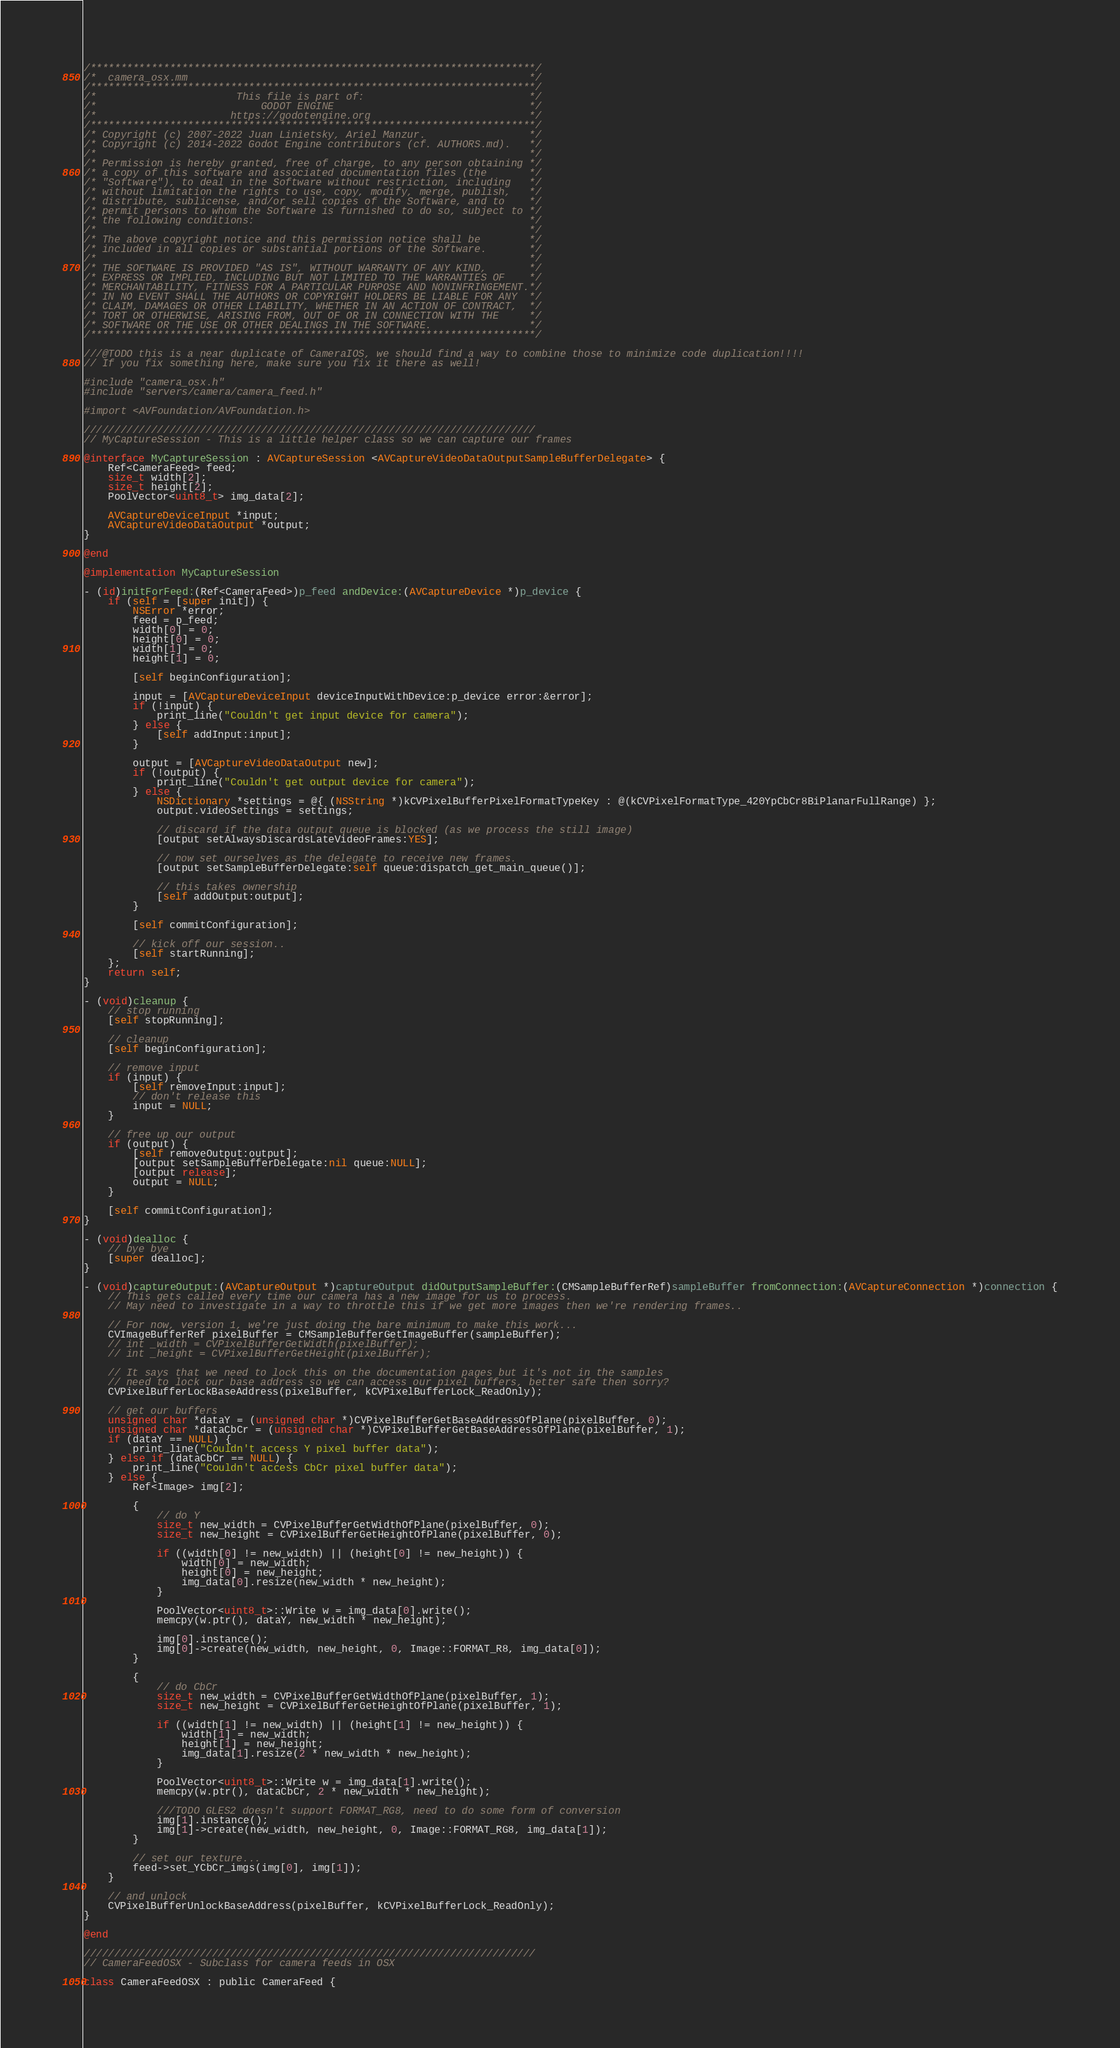Convert code to text. <code><loc_0><loc_0><loc_500><loc_500><_ObjectiveC_>/*************************************************************************/
/*  camera_osx.mm                                                        */
/*************************************************************************/
/*                       This file is part of:                           */
/*                           GODOT ENGINE                                */
/*                      https://godotengine.org                          */
/*************************************************************************/
/* Copyright (c) 2007-2022 Juan Linietsky, Ariel Manzur.                 */
/* Copyright (c) 2014-2022 Godot Engine contributors (cf. AUTHORS.md).   */
/*                                                                       */
/* Permission is hereby granted, free of charge, to any person obtaining */
/* a copy of this software and associated documentation files (the       */
/* "Software"), to deal in the Software without restriction, including   */
/* without limitation the rights to use, copy, modify, merge, publish,   */
/* distribute, sublicense, and/or sell copies of the Software, and to    */
/* permit persons to whom the Software is furnished to do so, subject to */
/* the following conditions:                                             */
/*                                                                       */
/* The above copyright notice and this permission notice shall be        */
/* included in all copies or substantial portions of the Software.       */
/*                                                                       */
/* THE SOFTWARE IS PROVIDED "AS IS", WITHOUT WARRANTY OF ANY KIND,       */
/* EXPRESS OR IMPLIED, INCLUDING BUT NOT LIMITED TO THE WARRANTIES OF    */
/* MERCHANTABILITY, FITNESS FOR A PARTICULAR PURPOSE AND NONINFRINGEMENT.*/
/* IN NO EVENT SHALL THE AUTHORS OR COPYRIGHT HOLDERS BE LIABLE FOR ANY  */
/* CLAIM, DAMAGES OR OTHER LIABILITY, WHETHER IN AN ACTION OF CONTRACT,  */
/* TORT OR OTHERWISE, ARISING FROM, OUT OF OR IN CONNECTION WITH THE     */
/* SOFTWARE OR THE USE OR OTHER DEALINGS IN THE SOFTWARE.                */
/*************************************************************************/

///@TODO this is a near duplicate of CameraIOS, we should find a way to combine those to minimize code duplication!!!!
// If you fix something here, make sure you fix it there as well!

#include "camera_osx.h"
#include "servers/camera/camera_feed.h"

#import <AVFoundation/AVFoundation.h>

//////////////////////////////////////////////////////////////////////////
// MyCaptureSession - This is a little helper class so we can capture our frames

@interface MyCaptureSession : AVCaptureSession <AVCaptureVideoDataOutputSampleBufferDelegate> {
	Ref<CameraFeed> feed;
	size_t width[2];
	size_t height[2];
	PoolVector<uint8_t> img_data[2];

	AVCaptureDeviceInput *input;
	AVCaptureVideoDataOutput *output;
}

@end

@implementation MyCaptureSession

- (id)initForFeed:(Ref<CameraFeed>)p_feed andDevice:(AVCaptureDevice *)p_device {
	if (self = [super init]) {
		NSError *error;
		feed = p_feed;
		width[0] = 0;
		height[0] = 0;
		width[1] = 0;
		height[1] = 0;

		[self beginConfiguration];

		input = [AVCaptureDeviceInput deviceInputWithDevice:p_device error:&error];
		if (!input) {
			print_line("Couldn't get input device for camera");
		} else {
			[self addInput:input];
		}

		output = [AVCaptureVideoDataOutput new];
		if (!output) {
			print_line("Couldn't get output device for camera");
		} else {
			NSDictionary *settings = @{ (NSString *)kCVPixelBufferPixelFormatTypeKey : @(kCVPixelFormatType_420YpCbCr8BiPlanarFullRange) };
			output.videoSettings = settings;

			// discard if the data output queue is blocked (as we process the still image)
			[output setAlwaysDiscardsLateVideoFrames:YES];

			// now set ourselves as the delegate to receive new frames.
			[output setSampleBufferDelegate:self queue:dispatch_get_main_queue()];

			// this takes ownership
			[self addOutput:output];
		}

		[self commitConfiguration];

		// kick off our session..
		[self startRunning];
	};
	return self;
}

- (void)cleanup {
	// stop running
	[self stopRunning];

	// cleanup
	[self beginConfiguration];

	// remove input
	if (input) {
		[self removeInput:input];
		// don't release this
		input = NULL;
	}

	// free up our output
	if (output) {
		[self removeOutput:output];
		[output setSampleBufferDelegate:nil queue:NULL];
		[output release];
		output = NULL;
	}

	[self commitConfiguration];
}

- (void)dealloc {
	// bye bye
	[super dealloc];
}

- (void)captureOutput:(AVCaptureOutput *)captureOutput didOutputSampleBuffer:(CMSampleBufferRef)sampleBuffer fromConnection:(AVCaptureConnection *)connection {
	// This gets called every time our camera has a new image for us to process.
	// May need to investigate in a way to throttle this if we get more images then we're rendering frames..

	// For now, version 1, we're just doing the bare minimum to make this work...
	CVImageBufferRef pixelBuffer = CMSampleBufferGetImageBuffer(sampleBuffer);
	// int _width = CVPixelBufferGetWidth(pixelBuffer);
	// int _height = CVPixelBufferGetHeight(pixelBuffer);

	// It says that we need to lock this on the documentation pages but it's not in the samples
	// need to lock our base address so we can access our pixel buffers, better safe then sorry?
	CVPixelBufferLockBaseAddress(pixelBuffer, kCVPixelBufferLock_ReadOnly);

	// get our buffers
	unsigned char *dataY = (unsigned char *)CVPixelBufferGetBaseAddressOfPlane(pixelBuffer, 0);
	unsigned char *dataCbCr = (unsigned char *)CVPixelBufferGetBaseAddressOfPlane(pixelBuffer, 1);
	if (dataY == NULL) {
		print_line("Couldn't access Y pixel buffer data");
	} else if (dataCbCr == NULL) {
		print_line("Couldn't access CbCr pixel buffer data");
	} else {
		Ref<Image> img[2];

		{
			// do Y
			size_t new_width = CVPixelBufferGetWidthOfPlane(pixelBuffer, 0);
			size_t new_height = CVPixelBufferGetHeightOfPlane(pixelBuffer, 0);

			if ((width[0] != new_width) || (height[0] != new_height)) {
				width[0] = new_width;
				height[0] = new_height;
				img_data[0].resize(new_width * new_height);
			}

			PoolVector<uint8_t>::Write w = img_data[0].write();
			memcpy(w.ptr(), dataY, new_width * new_height);

			img[0].instance();
			img[0]->create(new_width, new_height, 0, Image::FORMAT_R8, img_data[0]);
		}

		{
			// do CbCr
			size_t new_width = CVPixelBufferGetWidthOfPlane(pixelBuffer, 1);
			size_t new_height = CVPixelBufferGetHeightOfPlane(pixelBuffer, 1);

			if ((width[1] != new_width) || (height[1] != new_height)) {
				width[1] = new_width;
				height[1] = new_height;
				img_data[1].resize(2 * new_width * new_height);
			}

			PoolVector<uint8_t>::Write w = img_data[1].write();
			memcpy(w.ptr(), dataCbCr, 2 * new_width * new_height);

			///TODO GLES2 doesn't support FORMAT_RG8, need to do some form of conversion
			img[1].instance();
			img[1]->create(new_width, new_height, 0, Image::FORMAT_RG8, img_data[1]);
		}

		// set our texture...
		feed->set_YCbCr_imgs(img[0], img[1]);
	}

	// and unlock
	CVPixelBufferUnlockBaseAddress(pixelBuffer, kCVPixelBufferLock_ReadOnly);
}

@end

//////////////////////////////////////////////////////////////////////////
// CameraFeedOSX - Subclass for camera feeds in OSX

class CameraFeedOSX : public CameraFeed {</code> 